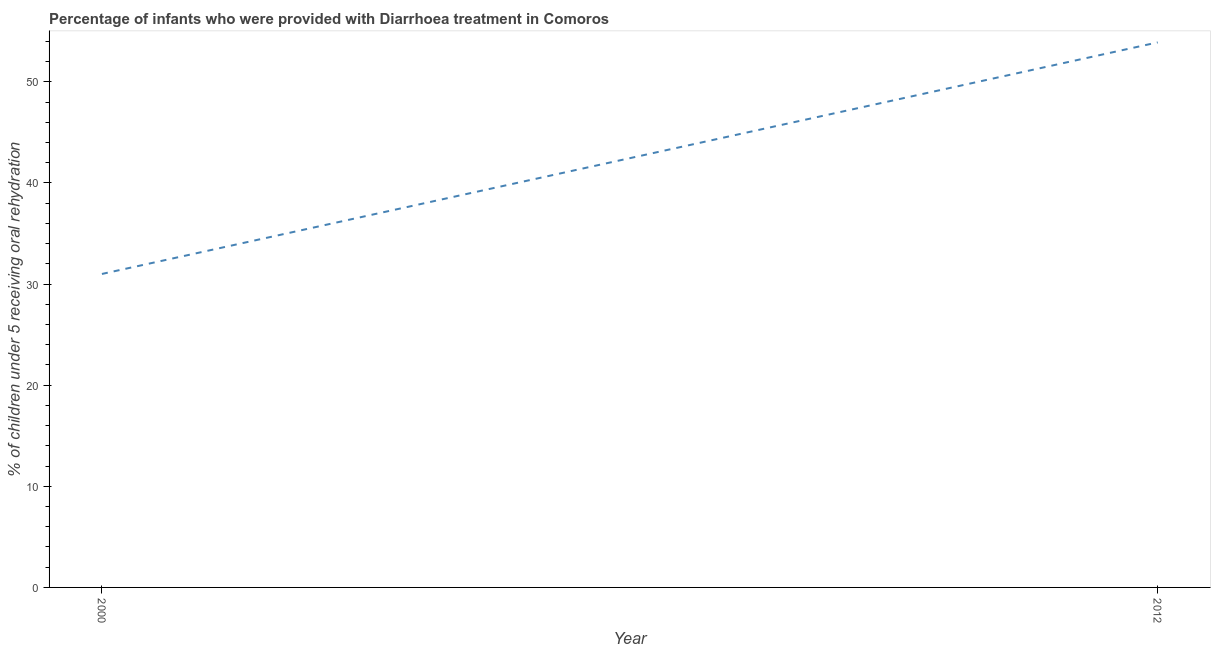What is the percentage of children who were provided with treatment diarrhoea in 2000?
Provide a short and direct response. 31. Across all years, what is the maximum percentage of children who were provided with treatment diarrhoea?
Offer a very short reply. 53.9. Across all years, what is the minimum percentage of children who were provided with treatment diarrhoea?
Give a very brief answer. 31. What is the sum of the percentage of children who were provided with treatment diarrhoea?
Keep it short and to the point. 84.9. What is the difference between the percentage of children who were provided with treatment diarrhoea in 2000 and 2012?
Provide a short and direct response. -22.9. What is the average percentage of children who were provided with treatment diarrhoea per year?
Your response must be concise. 42.45. What is the median percentage of children who were provided with treatment diarrhoea?
Your answer should be compact. 42.45. In how many years, is the percentage of children who were provided with treatment diarrhoea greater than 10 %?
Make the answer very short. 2. Do a majority of the years between 2000 and 2012 (inclusive) have percentage of children who were provided with treatment diarrhoea greater than 42 %?
Give a very brief answer. No. What is the ratio of the percentage of children who were provided with treatment diarrhoea in 2000 to that in 2012?
Ensure brevity in your answer.  0.58. Is the percentage of children who were provided with treatment diarrhoea in 2000 less than that in 2012?
Provide a short and direct response. Yes. How many years are there in the graph?
Ensure brevity in your answer.  2. What is the difference between two consecutive major ticks on the Y-axis?
Keep it short and to the point. 10. Are the values on the major ticks of Y-axis written in scientific E-notation?
Give a very brief answer. No. Does the graph contain any zero values?
Provide a succinct answer. No. Does the graph contain grids?
Give a very brief answer. No. What is the title of the graph?
Ensure brevity in your answer.  Percentage of infants who were provided with Diarrhoea treatment in Comoros. What is the label or title of the X-axis?
Your response must be concise. Year. What is the label or title of the Y-axis?
Offer a terse response. % of children under 5 receiving oral rehydration. What is the % of children under 5 receiving oral rehydration in 2012?
Give a very brief answer. 53.9. What is the difference between the % of children under 5 receiving oral rehydration in 2000 and 2012?
Ensure brevity in your answer.  -22.9. What is the ratio of the % of children under 5 receiving oral rehydration in 2000 to that in 2012?
Provide a succinct answer. 0.57. 